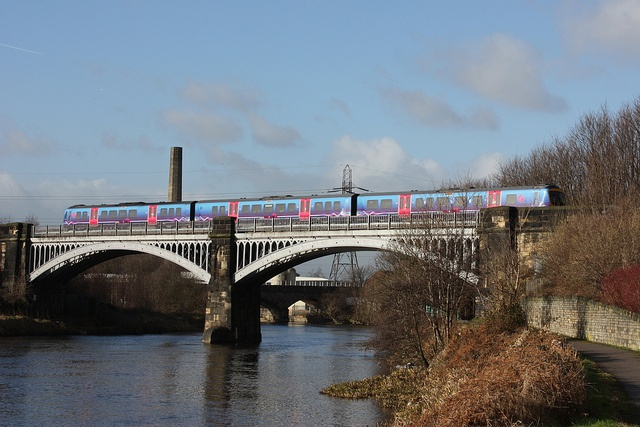Describe the objects in this image and their specific colors. I can see a train in darkgray, gray, and lightblue tones in this image. 